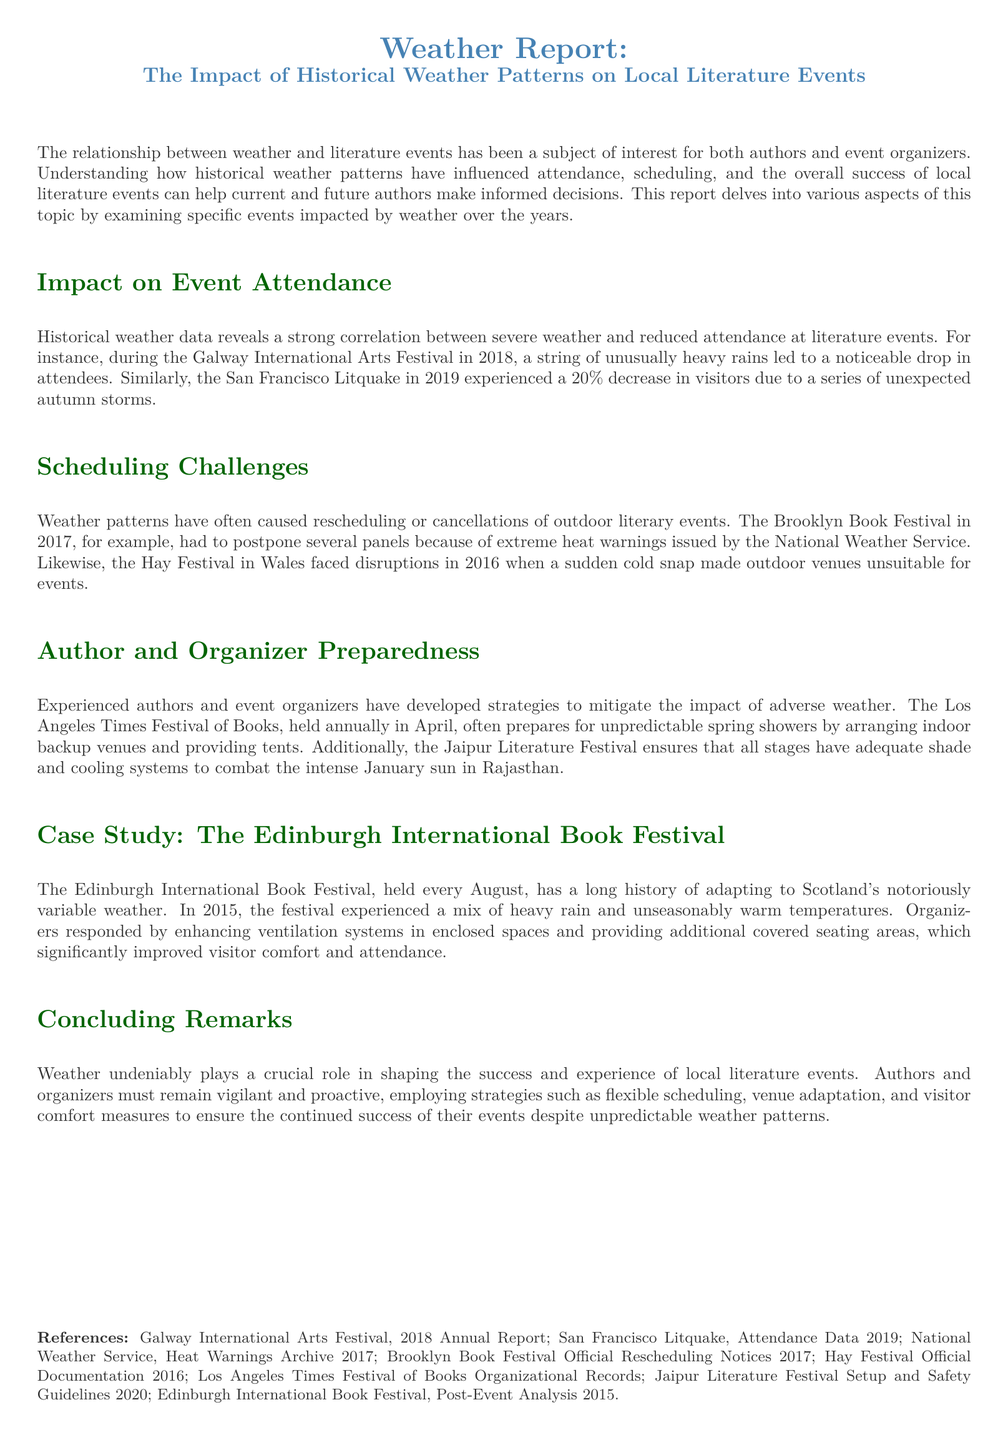What event had a drop in attendance due to heavy rains? The document states that the Galway International Arts Festival in 2018 experienced a noticeable drop in attendees because of unusually heavy rains.
Answer: Galway International Arts Festival What year did the San Francisco Litquake observe a 20% decrease in visitors? The report indicates that the San Francisco Litquake in 2019 faced a drop in attendance due to unexpected autumn storms.
Answer: 2019 What weather condition caused the Brooklyn Book Festival to postpone panels? The report mentions that extreme heat warnings led to the postponement of panels at the Brooklyn Book Festival in 2017.
Answer: Extreme heat What is a strategy used by the Los Angeles Times Festival of Books to deal with unpredictable weather? The document describes that the festival arranges indoor backup venues and provides tents to prepare for unpredictable spring showers.
Answer: Indoor backup venues What year did the Edinburgh International Book Festival adapt to a mix of heavy rain and warm temperatures? The report notes that in 2015, the Edinburgh International Book Festival had to adapt to variable weather conditions.
Answer: 2015 What measures did the Edinburgh International Book Festival take for visitor comfort? The document indicates that organizers enhanced ventilation systems and provided additional covered seating areas to improve visitor comfort.
Answer: Enhanced ventilation systems What type of analysis does the document conclude with? The document's concluding section emphasizes the ongoing need for adaptability regarding weather for authors and organizers at literature events.
Answer: Concluding remarks What is a common weather-related challenge faced by literary events? According to the report, scheduling challenges such as rescheduling or cancellations due to adverse weather are common among literary events.
Answer: Scheduling challenges 